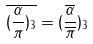Convert formula to latex. <formula><loc_0><loc_0><loc_500><loc_500>\overline { ( \frac { \alpha } { \pi } ) _ { 3 } } = ( \frac { \overline { \alpha } } { \overline { \pi } } ) _ { 3 }</formula> 